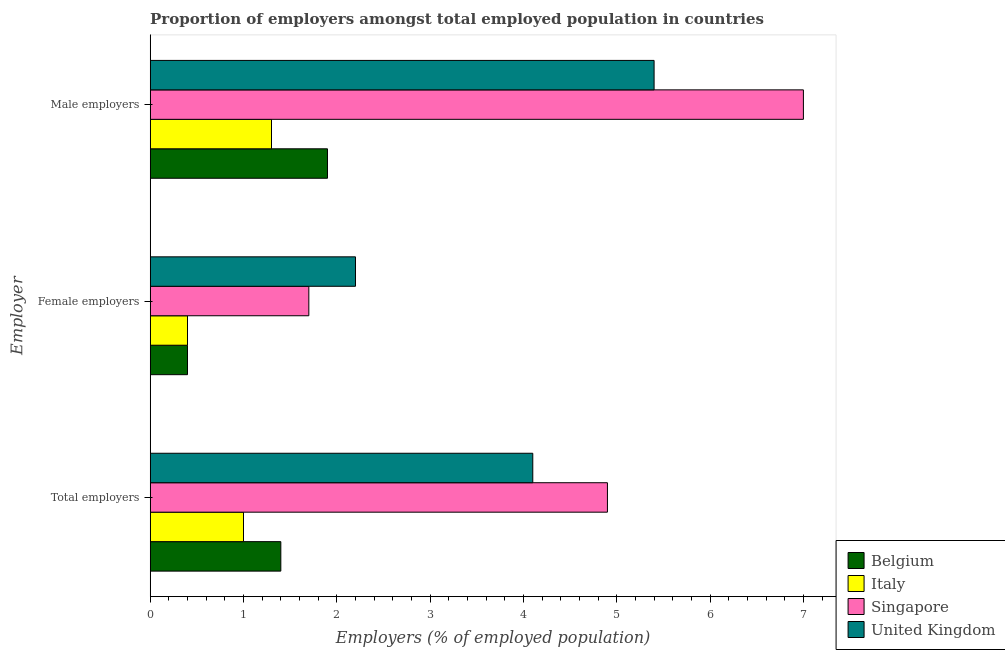How many groups of bars are there?
Ensure brevity in your answer.  3. Are the number of bars on each tick of the Y-axis equal?
Provide a succinct answer. Yes. How many bars are there on the 2nd tick from the top?
Make the answer very short. 4. How many bars are there on the 2nd tick from the bottom?
Offer a terse response. 4. What is the label of the 3rd group of bars from the top?
Your answer should be compact. Total employers. Across all countries, what is the maximum percentage of total employers?
Your answer should be compact. 4.9. Across all countries, what is the minimum percentage of male employers?
Ensure brevity in your answer.  1.3. In which country was the percentage of total employers maximum?
Provide a short and direct response. Singapore. In which country was the percentage of male employers minimum?
Your answer should be compact. Italy. What is the total percentage of total employers in the graph?
Ensure brevity in your answer.  11.4. What is the difference between the percentage of female employers in Singapore and that in United Kingdom?
Ensure brevity in your answer.  -0.5. What is the difference between the percentage of total employers in Italy and the percentage of female employers in Belgium?
Keep it short and to the point. 0.6. What is the average percentage of total employers per country?
Your answer should be compact. 2.85. What is the difference between the percentage of total employers and percentage of female employers in Italy?
Provide a succinct answer. 0.6. In how many countries, is the percentage of total employers greater than 1.8 %?
Make the answer very short. 2. What is the ratio of the percentage of female employers in Italy to that in United Kingdom?
Give a very brief answer. 0.18. Is the difference between the percentage of male employers in Italy and Singapore greater than the difference between the percentage of female employers in Italy and Singapore?
Ensure brevity in your answer.  No. What is the difference between the highest and the second highest percentage of total employers?
Ensure brevity in your answer.  0.8. What is the difference between the highest and the lowest percentage of male employers?
Give a very brief answer. 5.7. In how many countries, is the percentage of female employers greater than the average percentage of female employers taken over all countries?
Your response must be concise. 2. Is the sum of the percentage of male employers in Italy and Belgium greater than the maximum percentage of female employers across all countries?
Your response must be concise. Yes. What does the 3rd bar from the top in Total employers represents?
Give a very brief answer. Italy. What does the 3rd bar from the bottom in Male employers represents?
Give a very brief answer. Singapore. How many bars are there?
Your answer should be very brief. 12. How many countries are there in the graph?
Ensure brevity in your answer.  4. Does the graph contain any zero values?
Provide a succinct answer. No. Does the graph contain grids?
Your answer should be very brief. No. Where does the legend appear in the graph?
Provide a short and direct response. Bottom right. How many legend labels are there?
Your answer should be compact. 4. How are the legend labels stacked?
Give a very brief answer. Vertical. What is the title of the graph?
Offer a terse response. Proportion of employers amongst total employed population in countries. Does "Hungary" appear as one of the legend labels in the graph?
Your response must be concise. No. What is the label or title of the X-axis?
Keep it short and to the point. Employers (% of employed population). What is the label or title of the Y-axis?
Your response must be concise. Employer. What is the Employers (% of employed population) in Belgium in Total employers?
Your answer should be very brief. 1.4. What is the Employers (% of employed population) in Singapore in Total employers?
Keep it short and to the point. 4.9. What is the Employers (% of employed population) of United Kingdom in Total employers?
Ensure brevity in your answer.  4.1. What is the Employers (% of employed population) of Belgium in Female employers?
Offer a terse response. 0.4. What is the Employers (% of employed population) in Italy in Female employers?
Ensure brevity in your answer.  0.4. What is the Employers (% of employed population) in Singapore in Female employers?
Your answer should be very brief. 1.7. What is the Employers (% of employed population) of United Kingdom in Female employers?
Keep it short and to the point. 2.2. What is the Employers (% of employed population) in Belgium in Male employers?
Provide a short and direct response. 1.9. What is the Employers (% of employed population) in Italy in Male employers?
Your answer should be very brief. 1.3. What is the Employers (% of employed population) of Singapore in Male employers?
Offer a very short reply. 7. What is the Employers (% of employed population) of United Kingdom in Male employers?
Offer a terse response. 5.4. Across all Employer, what is the maximum Employers (% of employed population) of Belgium?
Offer a very short reply. 1.9. Across all Employer, what is the maximum Employers (% of employed population) of Italy?
Give a very brief answer. 1.3. Across all Employer, what is the maximum Employers (% of employed population) of United Kingdom?
Provide a succinct answer. 5.4. Across all Employer, what is the minimum Employers (% of employed population) of Belgium?
Make the answer very short. 0.4. Across all Employer, what is the minimum Employers (% of employed population) of Italy?
Your response must be concise. 0.4. Across all Employer, what is the minimum Employers (% of employed population) in Singapore?
Your response must be concise. 1.7. Across all Employer, what is the minimum Employers (% of employed population) of United Kingdom?
Give a very brief answer. 2.2. What is the difference between the Employers (% of employed population) in Belgium in Total employers and that in Female employers?
Provide a short and direct response. 1. What is the difference between the Employers (% of employed population) of Italy in Total employers and that in Male employers?
Your response must be concise. -0.3. What is the difference between the Employers (% of employed population) in Singapore in Female employers and that in Male employers?
Make the answer very short. -5.3. What is the difference between the Employers (% of employed population) of United Kingdom in Female employers and that in Male employers?
Provide a succinct answer. -3.2. What is the difference between the Employers (% of employed population) of Belgium in Total employers and the Employers (% of employed population) of Italy in Female employers?
Make the answer very short. 1. What is the difference between the Employers (% of employed population) in Belgium in Total employers and the Employers (% of employed population) in Singapore in Female employers?
Ensure brevity in your answer.  -0.3. What is the difference between the Employers (% of employed population) of Belgium in Total employers and the Employers (% of employed population) of United Kingdom in Female employers?
Provide a succinct answer. -0.8. What is the difference between the Employers (% of employed population) in Italy in Total employers and the Employers (% of employed population) in United Kingdom in Female employers?
Your answer should be very brief. -1.2. What is the difference between the Employers (% of employed population) in Belgium in Total employers and the Employers (% of employed population) in Singapore in Male employers?
Offer a terse response. -5.6. What is the difference between the Employers (% of employed population) in Italy in Total employers and the Employers (% of employed population) in Singapore in Male employers?
Offer a terse response. -6. What is the difference between the Employers (% of employed population) in Italy in Total employers and the Employers (% of employed population) in United Kingdom in Male employers?
Keep it short and to the point. -4.4. What is the difference between the Employers (% of employed population) of Singapore in Total employers and the Employers (% of employed population) of United Kingdom in Male employers?
Your answer should be very brief. -0.5. What is the difference between the Employers (% of employed population) of Belgium in Female employers and the Employers (% of employed population) of Singapore in Male employers?
Offer a very short reply. -6.6. What is the difference between the Employers (% of employed population) in Belgium in Female employers and the Employers (% of employed population) in United Kingdom in Male employers?
Make the answer very short. -5. What is the difference between the Employers (% of employed population) of Singapore in Female employers and the Employers (% of employed population) of United Kingdom in Male employers?
Keep it short and to the point. -3.7. What is the average Employers (% of employed population) in Belgium per Employer?
Give a very brief answer. 1.23. What is the average Employers (% of employed population) in Italy per Employer?
Your response must be concise. 0.9. What is the average Employers (% of employed population) of Singapore per Employer?
Offer a very short reply. 4.53. What is the average Employers (% of employed population) of United Kingdom per Employer?
Offer a very short reply. 3.9. What is the difference between the Employers (% of employed population) of Belgium and Employers (% of employed population) of Italy in Total employers?
Offer a very short reply. 0.4. What is the difference between the Employers (% of employed population) in Belgium and Employers (% of employed population) in Singapore in Total employers?
Give a very brief answer. -3.5. What is the difference between the Employers (% of employed population) in Belgium and Employers (% of employed population) in United Kingdom in Total employers?
Your response must be concise. -2.7. What is the difference between the Employers (% of employed population) of Singapore and Employers (% of employed population) of United Kingdom in Total employers?
Your answer should be very brief. 0.8. What is the difference between the Employers (% of employed population) of Belgium and Employers (% of employed population) of Italy in Female employers?
Offer a terse response. 0. What is the difference between the Employers (% of employed population) of Belgium and Employers (% of employed population) of Singapore in Female employers?
Give a very brief answer. -1.3. What is the difference between the Employers (% of employed population) of Italy and Employers (% of employed population) of Singapore in Female employers?
Offer a terse response. -1.3. What is the difference between the Employers (% of employed population) of Singapore and Employers (% of employed population) of United Kingdom in Female employers?
Your response must be concise. -0.5. What is the difference between the Employers (% of employed population) in Belgium and Employers (% of employed population) in Singapore in Male employers?
Give a very brief answer. -5.1. What is the ratio of the Employers (% of employed population) in Singapore in Total employers to that in Female employers?
Ensure brevity in your answer.  2.88. What is the ratio of the Employers (% of employed population) in United Kingdom in Total employers to that in Female employers?
Your answer should be compact. 1.86. What is the ratio of the Employers (% of employed population) of Belgium in Total employers to that in Male employers?
Offer a very short reply. 0.74. What is the ratio of the Employers (% of employed population) of Italy in Total employers to that in Male employers?
Your answer should be very brief. 0.77. What is the ratio of the Employers (% of employed population) of United Kingdom in Total employers to that in Male employers?
Ensure brevity in your answer.  0.76. What is the ratio of the Employers (% of employed population) of Belgium in Female employers to that in Male employers?
Give a very brief answer. 0.21. What is the ratio of the Employers (% of employed population) in Italy in Female employers to that in Male employers?
Offer a terse response. 0.31. What is the ratio of the Employers (% of employed population) in Singapore in Female employers to that in Male employers?
Ensure brevity in your answer.  0.24. What is the ratio of the Employers (% of employed population) of United Kingdom in Female employers to that in Male employers?
Your answer should be compact. 0.41. What is the difference between the highest and the second highest Employers (% of employed population) of Singapore?
Ensure brevity in your answer.  2.1. What is the difference between the highest and the lowest Employers (% of employed population) in Belgium?
Give a very brief answer. 1.5. What is the difference between the highest and the lowest Employers (% of employed population) in Italy?
Offer a terse response. 0.9. What is the difference between the highest and the lowest Employers (% of employed population) of Singapore?
Keep it short and to the point. 5.3. 